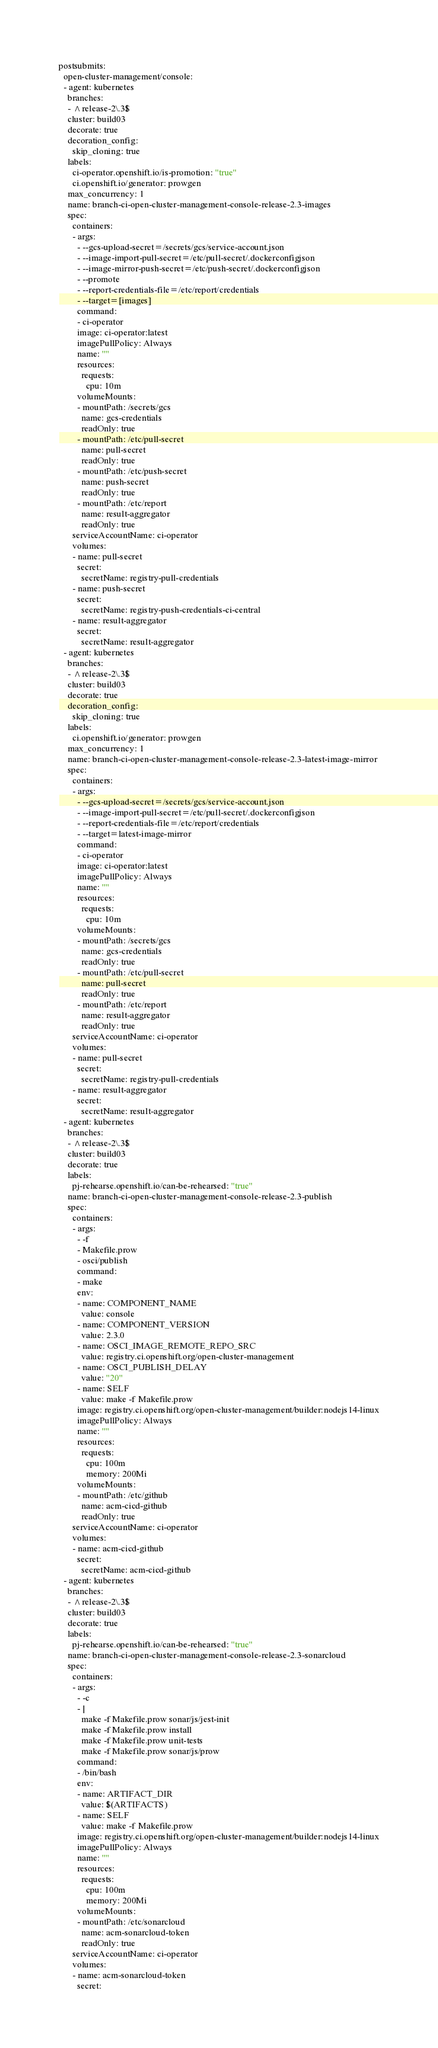<code> <loc_0><loc_0><loc_500><loc_500><_YAML_>postsubmits:
  open-cluster-management/console:
  - agent: kubernetes
    branches:
    - ^release-2\.3$
    cluster: build03
    decorate: true
    decoration_config:
      skip_cloning: true
    labels:
      ci-operator.openshift.io/is-promotion: "true"
      ci.openshift.io/generator: prowgen
    max_concurrency: 1
    name: branch-ci-open-cluster-management-console-release-2.3-images
    spec:
      containers:
      - args:
        - --gcs-upload-secret=/secrets/gcs/service-account.json
        - --image-import-pull-secret=/etc/pull-secret/.dockerconfigjson
        - --image-mirror-push-secret=/etc/push-secret/.dockerconfigjson
        - --promote
        - --report-credentials-file=/etc/report/credentials
        - --target=[images]
        command:
        - ci-operator
        image: ci-operator:latest
        imagePullPolicy: Always
        name: ""
        resources:
          requests:
            cpu: 10m
        volumeMounts:
        - mountPath: /secrets/gcs
          name: gcs-credentials
          readOnly: true
        - mountPath: /etc/pull-secret
          name: pull-secret
          readOnly: true
        - mountPath: /etc/push-secret
          name: push-secret
          readOnly: true
        - mountPath: /etc/report
          name: result-aggregator
          readOnly: true
      serviceAccountName: ci-operator
      volumes:
      - name: pull-secret
        secret:
          secretName: registry-pull-credentials
      - name: push-secret
        secret:
          secretName: registry-push-credentials-ci-central
      - name: result-aggregator
        secret:
          secretName: result-aggregator
  - agent: kubernetes
    branches:
    - ^release-2\.3$
    cluster: build03
    decorate: true
    decoration_config:
      skip_cloning: true
    labels:
      ci.openshift.io/generator: prowgen
    max_concurrency: 1
    name: branch-ci-open-cluster-management-console-release-2.3-latest-image-mirror
    spec:
      containers:
      - args:
        - --gcs-upload-secret=/secrets/gcs/service-account.json
        - --image-import-pull-secret=/etc/pull-secret/.dockerconfigjson
        - --report-credentials-file=/etc/report/credentials
        - --target=latest-image-mirror
        command:
        - ci-operator
        image: ci-operator:latest
        imagePullPolicy: Always
        name: ""
        resources:
          requests:
            cpu: 10m
        volumeMounts:
        - mountPath: /secrets/gcs
          name: gcs-credentials
          readOnly: true
        - mountPath: /etc/pull-secret
          name: pull-secret
          readOnly: true
        - mountPath: /etc/report
          name: result-aggregator
          readOnly: true
      serviceAccountName: ci-operator
      volumes:
      - name: pull-secret
        secret:
          secretName: registry-pull-credentials
      - name: result-aggregator
        secret:
          secretName: result-aggregator
  - agent: kubernetes
    branches:
    - ^release-2\.3$
    cluster: build03
    decorate: true
    labels:
      pj-rehearse.openshift.io/can-be-rehearsed: "true"
    name: branch-ci-open-cluster-management-console-release-2.3-publish
    spec:
      containers:
      - args:
        - -f
        - Makefile.prow
        - osci/publish
        command:
        - make
        env:
        - name: COMPONENT_NAME
          value: console
        - name: COMPONENT_VERSION
          value: 2.3.0
        - name: OSCI_IMAGE_REMOTE_REPO_SRC
          value: registry.ci.openshift.org/open-cluster-management
        - name: OSCI_PUBLISH_DELAY
          value: "20"
        - name: SELF
          value: make -f Makefile.prow
        image: registry.ci.openshift.org/open-cluster-management/builder:nodejs14-linux
        imagePullPolicy: Always
        name: ""
        resources:
          requests:
            cpu: 100m
            memory: 200Mi
        volumeMounts:
        - mountPath: /etc/github
          name: acm-cicd-github
          readOnly: true
      serviceAccountName: ci-operator
      volumes:
      - name: acm-cicd-github
        secret:
          secretName: acm-cicd-github
  - agent: kubernetes
    branches:
    - ^release-2\.3$
    cluster: build03
    decorate: true
    labels:
      pj-rehearse.openshift.io/can-be-rehearsed: "true"
    name: branch-ci-open-cluster-management-console-release-2.3-sonarcloud
    spec:
      containers:
      - args:
        - -c
        - |
          make -f Makefile.prow sonar/js/jest-init
          make -f Makefile.prow install
          make -f Makefile.prow unit-tests
          make -f Makefile.prow sonar/js/prow
        command:
        - /bin/bash
        env:
        - name: ARTIFACT_DIR
          value: $(ARTIFACTS)
        - name: SELF
          value: make -f Makefile.prow
        image: registry.ci.openshift.org/open-cluster-management/builder:nodejs14-linux
        imagePullPolicy: Always
        name: ""
        resources:
          requests:
            cpu: 100m
            memory: 200Mi
        volumeMounts:
        - mountPath: /etc/sonarcloud
          name: acm-sonarcloud-token
          readOnly: true
      serviceAccountName: ci-operator
      volumes:
      - name: acm-sonarcloud-token
        secret:</code> 